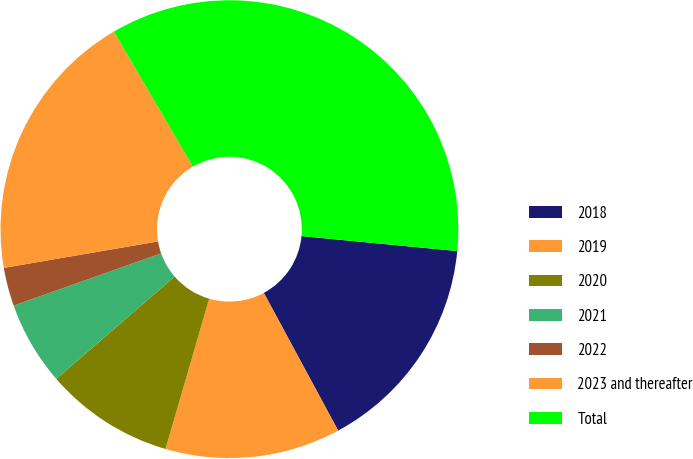Convert chart to OTSL. <chart><loc_0><loc_0><loc_500><loc_500><pie_chart><fcel>2018<fcel>2019<fcel>2020<fcel>2021<fcel>2022<fcel>2023 and thereafter<fcel>Total<nl><fcel>15.6%<fcel>12.38%<fcel>9.15%<fcel>5.93%<fcel>2.71%<fcel>19.28%<fcel>34.95%<nl></chart> 